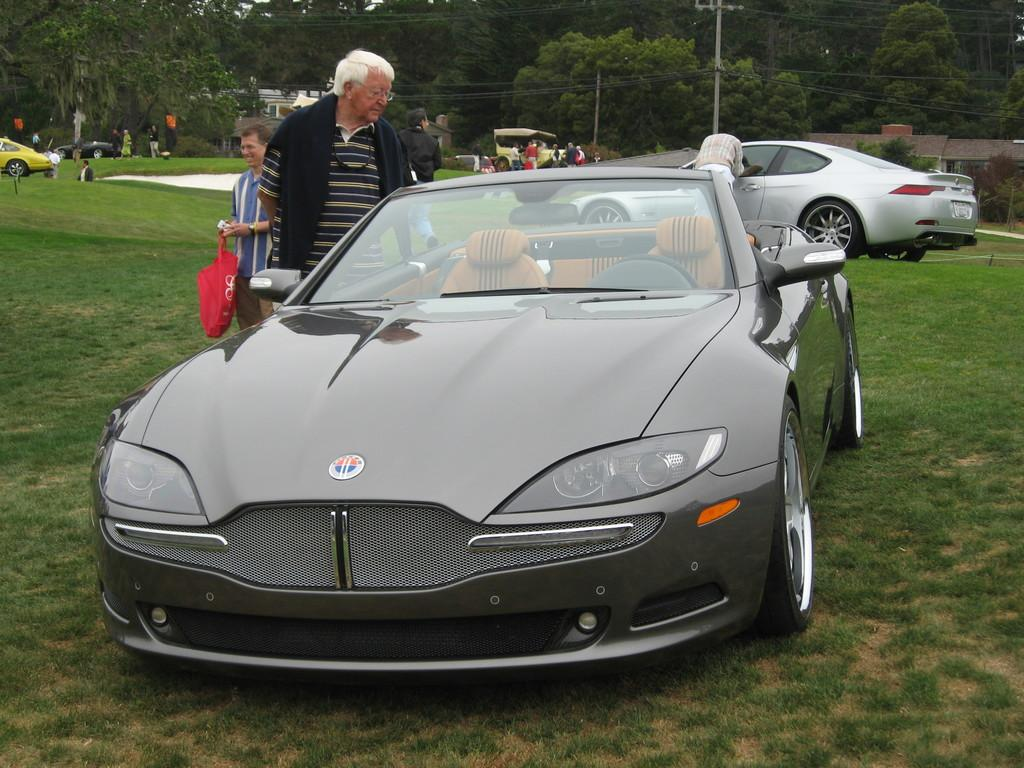What type of environment is depicted in the image? The image is an outside view. What is covering the ground in the image? There is grass on the ground. What else can be seen on the ground in the image? There are vehicles and people visible on the ground. What is present in the background of the image? There is a pole and many trees in the background. How many eggs are being held by the parent in the image? There is no parent or eggs present in the image. What type of drain is visible in the image? There is no drain present in the image. 